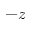<formula> <loc_0><loc_0><loc_500><loc_500>- z</formula> 